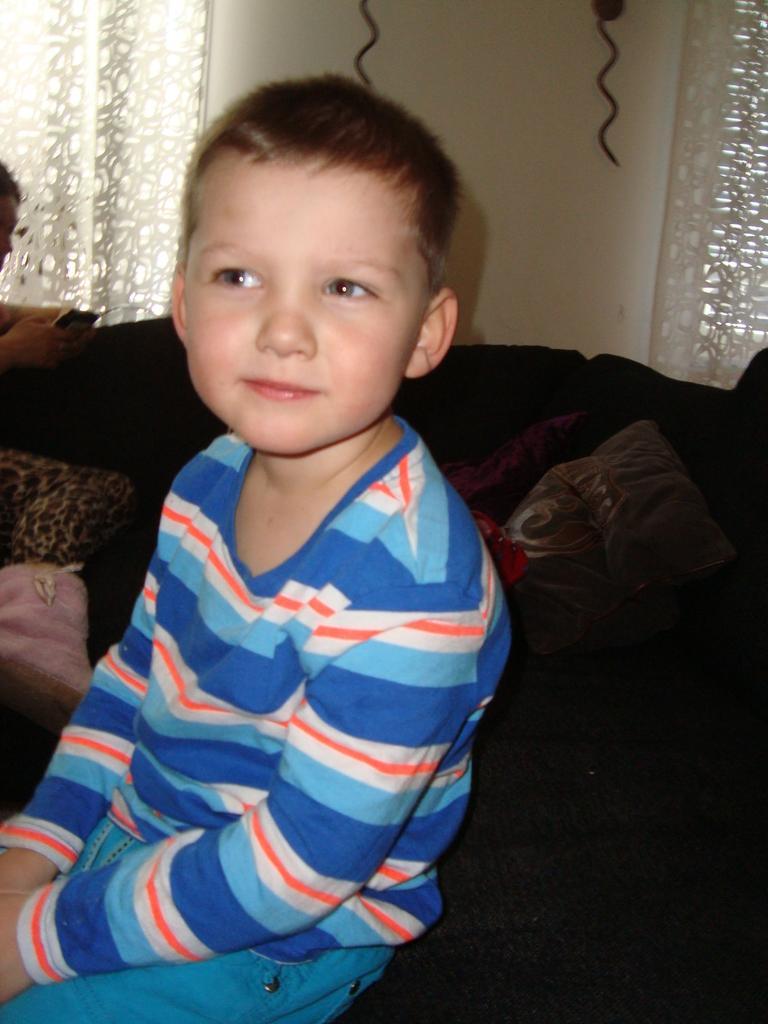Could you give a brief overview of what you see in this image? A boy is sitting in a room wearing a blue dress. Behind him there are cushions. There are white curtains at the back. 